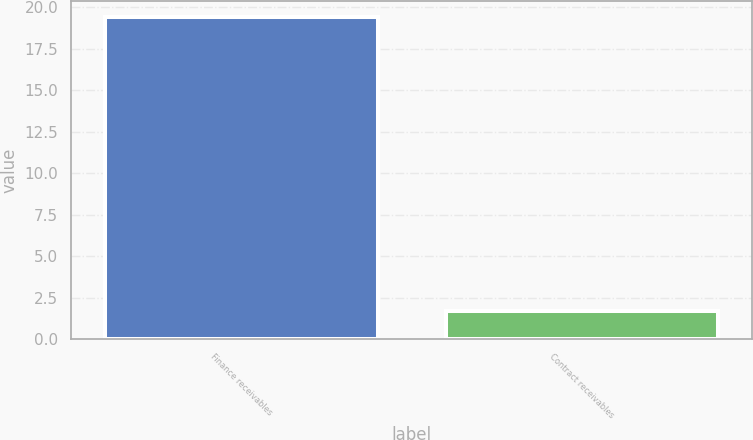Convert chart to OTSL. <chart><loc_0><loc_0><loc_500><loc_500><bar_chart><fcel>Finance receivables<fcel>Contract receivables<nl><fcel>19.4<fcel>1.7<nl></chart> 